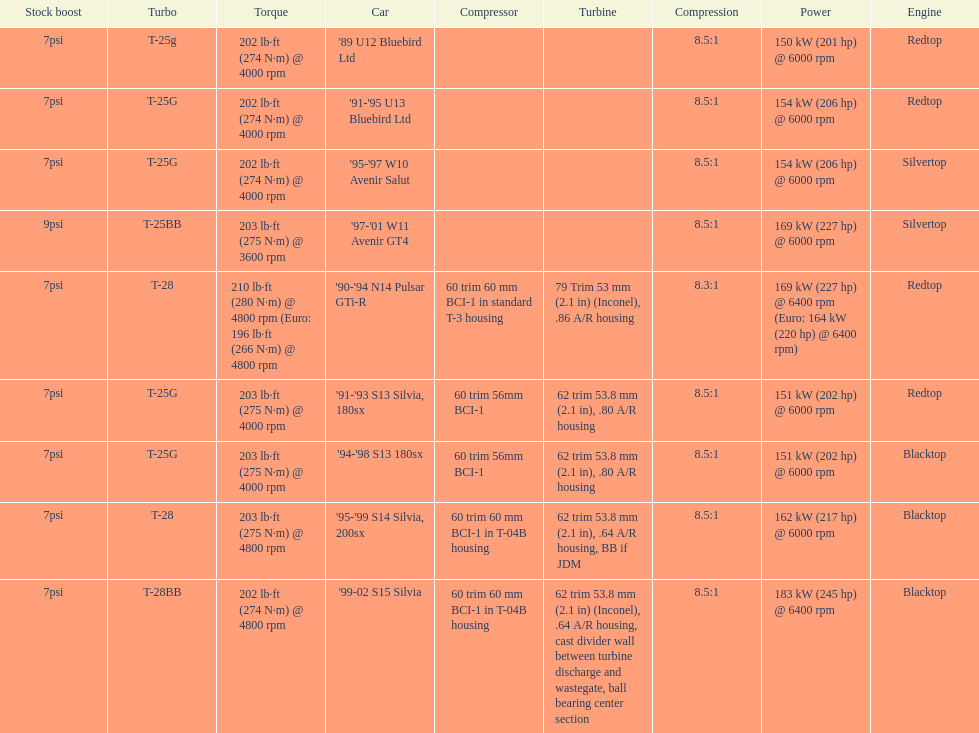Which engines are the same as the first entry ('89 u12 bluebird ltd)? '91-'95 U13 Bluebird Ltd, '90-'94 N14 Pulsar GTi-R, '91-'93 S13 Silvia, 180sx. 